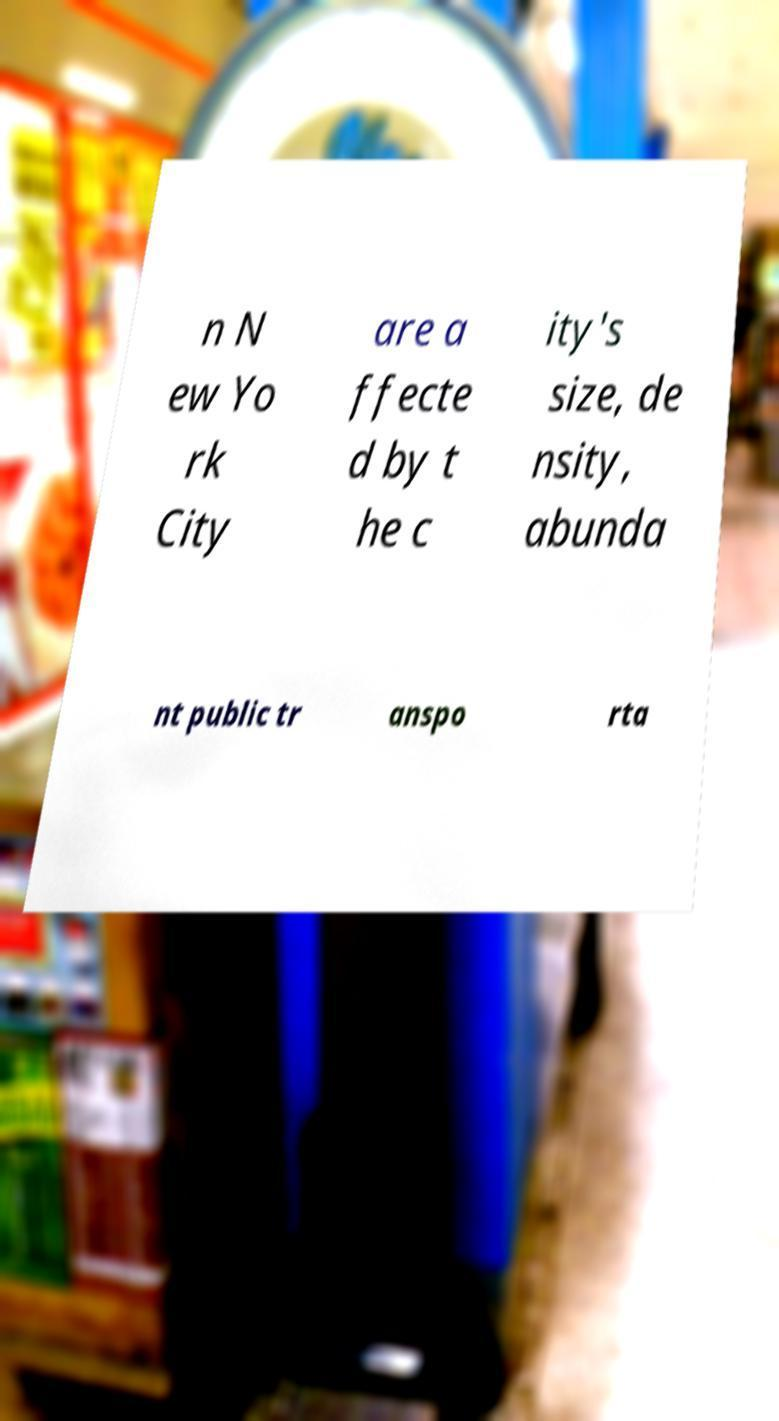Can you read and provide the text displayed in the image?This photo seems to have some interesting text. Can you extract and type it out for me? n N ew Yo rk City are a ffecte d by t he c ity's size, de nsity, abunda nt public tr anspo rta 